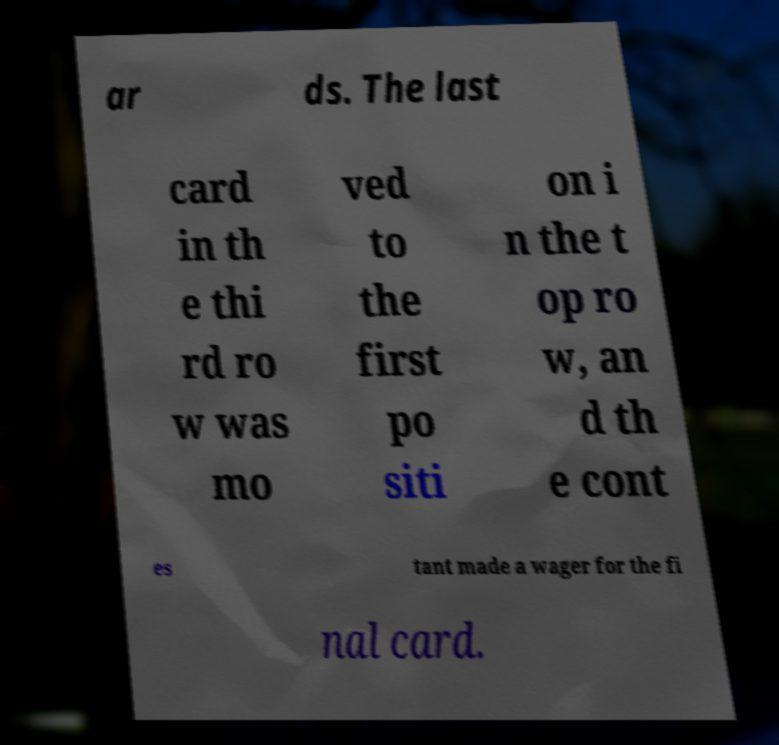What messages or text are displayed in this image? I need them in a readable, typed format. ar ds. The last card in th e thi rd ro w was mo ved to the first po siti on i n the t op ro w, an d th e cont es tant made a wager for the fi nal card. 